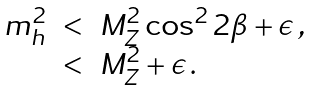<formula> <loc_0><loc_0><loc_500><loc_500>\begin{array} { r c l } m _ { h } ^ { 2 } & < & M _ { Z } ^ { 2 } \cos ^ { 2 } 2 \beta + \epsilon \, , \\ & < & M _ { Z } ^ { 2 } + \epsilon \, . \end{array}</formula> 